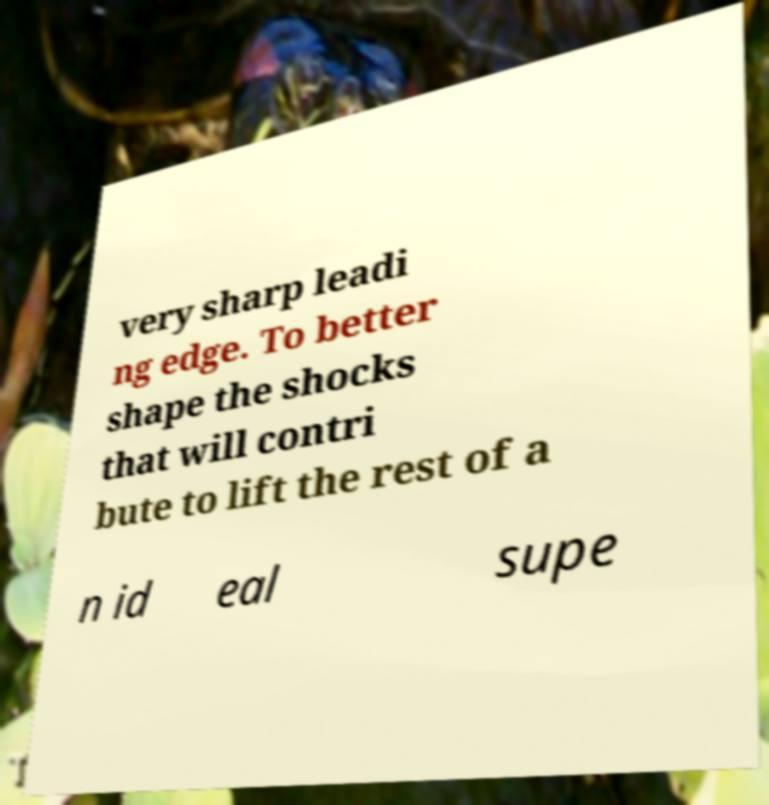Please read and relay the text visible in this image. What does it say? very sharp leadi ng edge. To better shape the shocks that will contri bute to lift the rest of a n id eal supe 